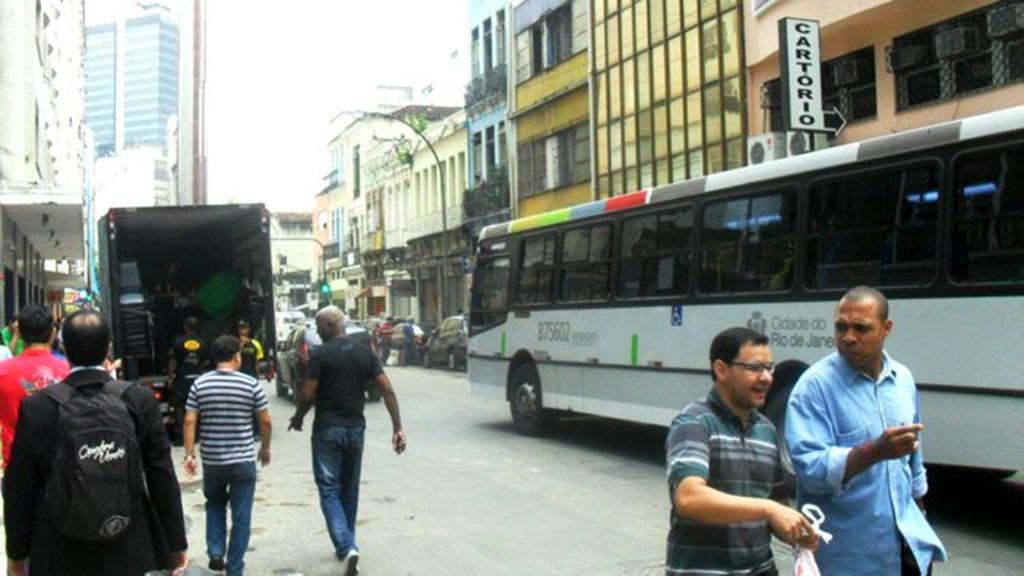What is the white sign showing?
Ensure brevity in your answer.  Cartorio. What is the number on the bus?
Provide a succinct answer. 875602. 